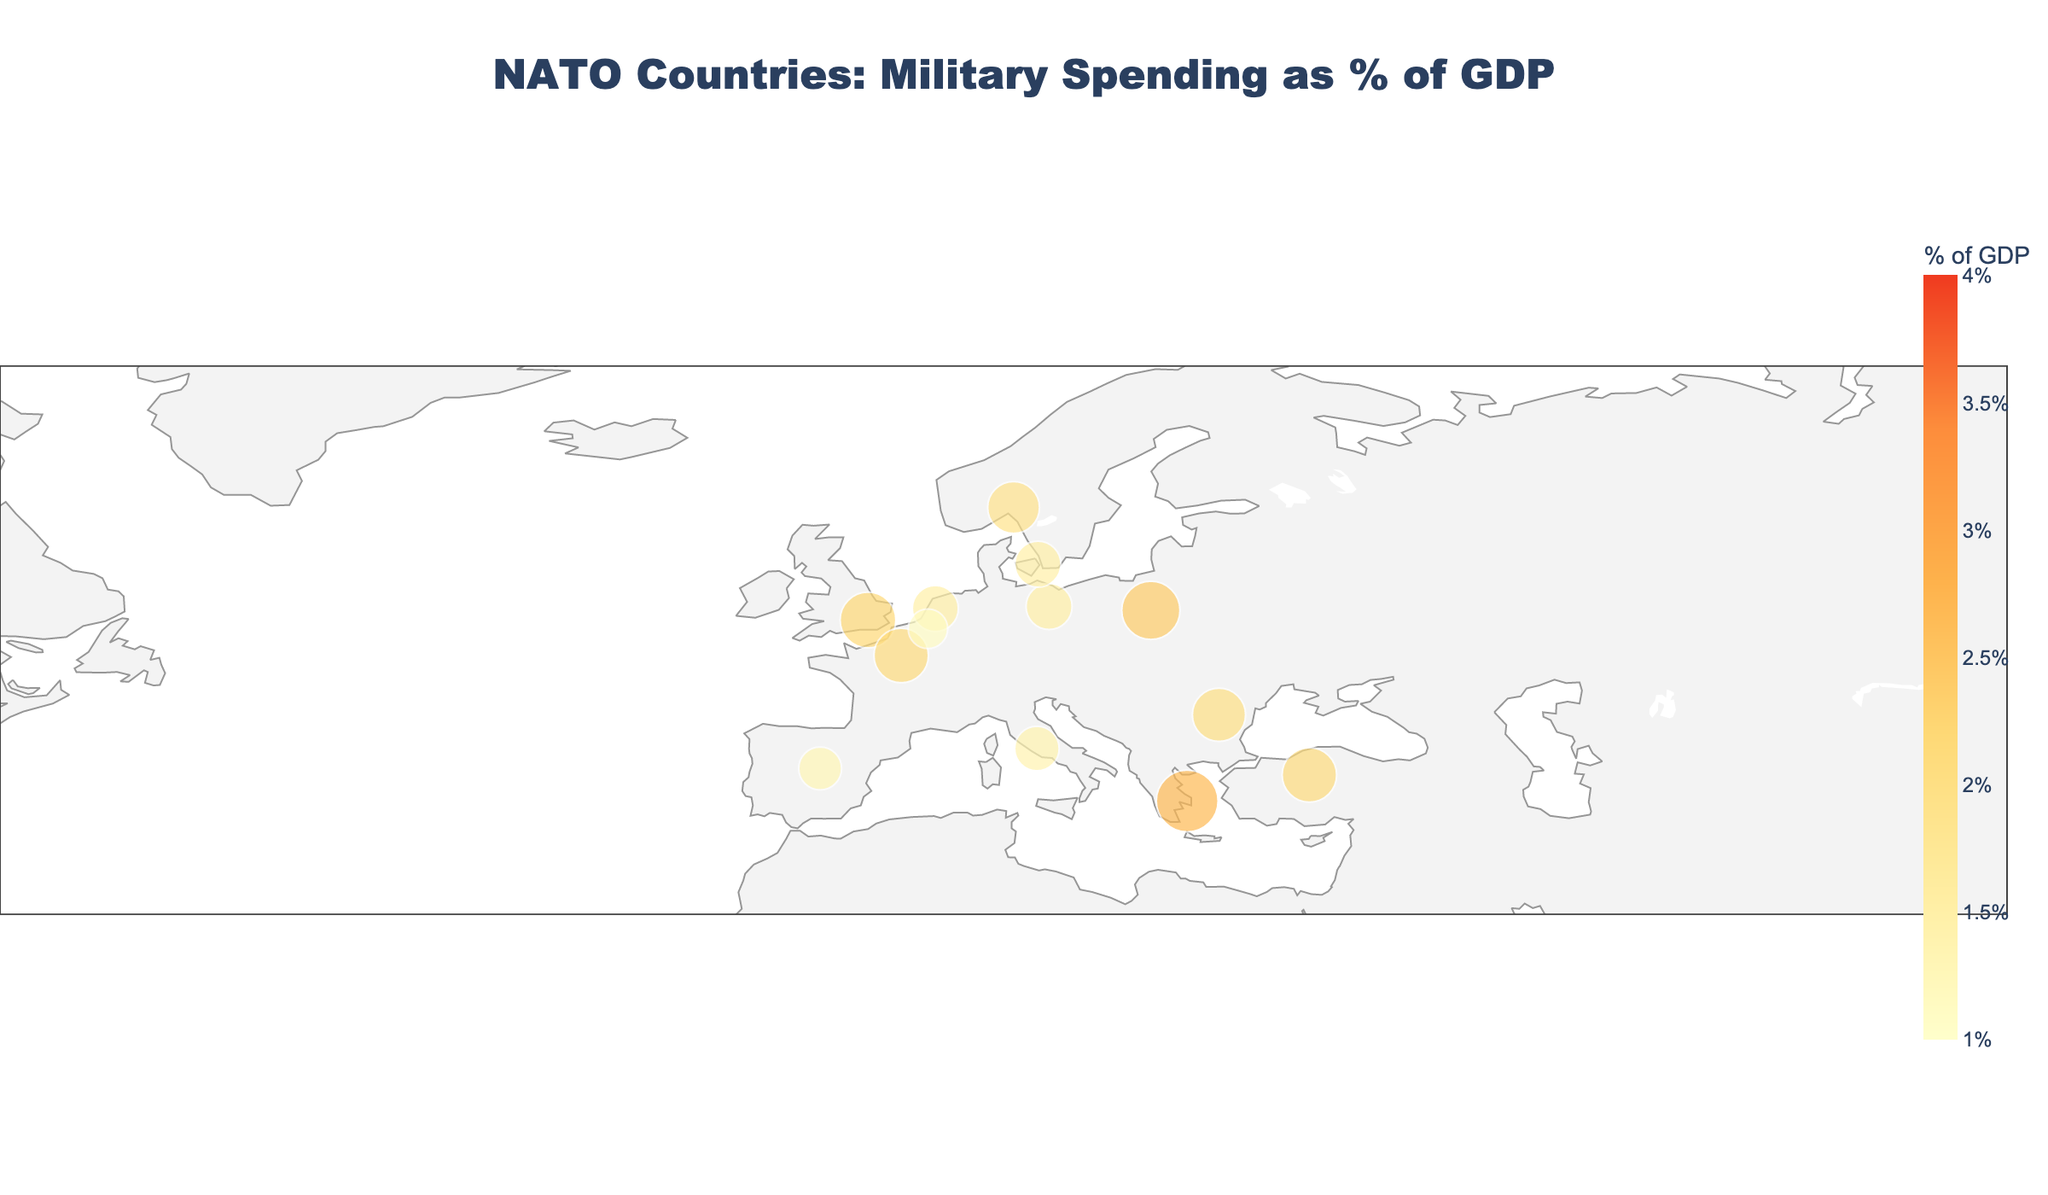What's the title of the figure? The title is typically located at the top center of the figure. In this case, it reads "NATO Countries: Military Spending as % of GDP"
Answer: NATO Countries: Military Spending as % of GDP How many countries are represented in the figure? By counting the individual data points (or labels) in the figure, we can determine the number of countries represented. There are dots with labels next to them which indicate each country.
Answer: 15 Which country spends the highest percentage of its GDP on military? The size and color of the data points indicate the military spending percentage. The point with the largest size and the darkest color represents the highest spending. This is the United States.
Answer: United States What is the range of military spending percentages shown on the color bar? The color bar on the right side of the figure indicates the range of military spending percentages. It includes spending from the smallest percentage to the highest percentage shown.
Answer: 1% to 4% What is the average military spending percentage among the represented NATO countries? To calculate the average, sum all the military spending percentages and divide by the number of countries. (3.7 + 2.2 + 2.1 + 1.5 + 1.4 + 1.3 + 2.4 + 2.1 + 2.7 + 2.0 + 1.9 + 1.5 + 1.5 + 1.4 + 1.1) / 15 = 30.8 / 15 = 2.05
Answer: 2.05 Which countries spend less than 1.5% of their GDP on military? By checking the data points and labels, we can identify which points are paired with a percentage less than 1.5%. These countries are Italy, Spain, Canada, and Belgium.
Answer: Italy, Spain, Canada, Belgium Which European country spends the most on its military as a percentage of GDP? Among the European countries, we have to identify the country with the highest military spending percentage represented by the darkest color and largest size. This is Greece.
Answer: Greece What is the difference in military spending percentage between the country with the highest spending and the country with the lowest? The highest is the United States with 3.7%, and the lowest is Belgium with 1.1%. The difference is 3.7 - 1.1 = 2.6
Answer: 2.6 Are there any countries with exactly the same percentage of military spending? By observing the data points, we notice that Germany, Denmark, and the Netherlands all spend 1.5% of their GDP on the military.
Answer: Germany, Denmark, Netherlands In which direction do we need to move from the United Kingdom to reach the country with the highest military spending? To find the direction, locate the United Kingdom and the United States on the map. Moving westward from the United Kingdom will lead to the United States, which has the highest military spending.
Answer: West 